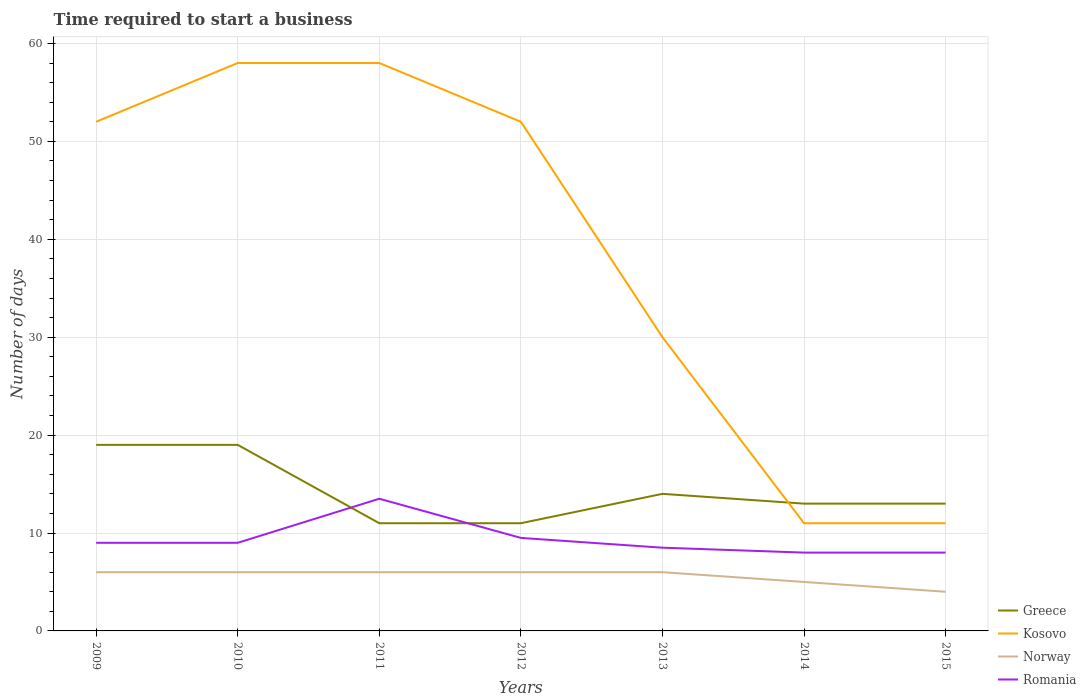Does the line corresponding to Norway intersect with the line corresponding to Greece?
Make the answer very short. No. Across all years, what is the maximum number of days required to start a business in Kosovo?
Make the answer very short. 11. In which year was the number of days required to start a business in Kosovo maximum?
Your answer should be compact. 2014. What is the total number of days required to start a business in Kosovo in the graph?
Your answer should be compact. 41. What is the difference between the highest and the lowest number of days required to start a business in Kosovo?
Offer a very short reply. 4. Is the number of days required to start a business in Romania strictly greater than the number of days required to start a business in Norway over the years?
Provide a short and direct response. No. What is the difference between two consecutive major ticks on the Y-axis?
Give a very brief answer. 10. Where does the legend appear in the graph?
Give a very brief answer. Bottom right. What is the title of the graph?
Offer a very short reply. Time required to start a business. Does "Togo" appear as one of the legend labels in the graph?
Offer a very short reply. No. What is the label or title of the Y-axis?
Give a very brief answer. Number of days. What is the Number of days in Kosovo in 2009?
Your answer should be compact. 52. What is the Number of days of Norway in 2009?
Your answer should be very brief. 6. What is the Number of days of Romania in 2009?
Provide a short and direct response. 9. What is the Number of days of Greece in 2010?
Your response must be concise. 19. What is the Number of days of Norway in 2010?
Keep it short and to the point. 6. What is the Number of days of Romania in 2010?
Give a very brief answer. 9. What is the Number of days in Greece in 2011?
Your answer should be very brief. 11. What is the Number of days of Romania in 2011?
Provide a short and direct response. 13.5. What is the Number of days in Greece in 2012?
Give a very brief answer. 11. What is the Number of days of Kosovo in 2012?
Provide a short and direct response. 52. What is the Number of days of Greece in 2014?
Make the answer very short. 13. What is the Number of days of Romania in 2014?
Your response must be concise. 8. What is the Number of days of Greece in 2015?
Your response must be concise. 13. What is the Number of days of Kosovo in 2015?
Provide a short and direct response. 11. Across all years, what is the maximum Number of days in Kosovo?
Your answer should be compact. 58. Across all years, what is the minimum Number of days in Romania?
Keep it short and to the point. 8. What is the total Number of days in Greece in the graph?
Ensure brevity in your answer.  100. What is the total Number of days of Kosovo in the graph?
Provide a short and direct response. 272. What is the total Number of days of Norway in the graph?
Ensure brevity in your answer.  39. What is the total Number of days of Romania in the graph?
Provide a succinct answer. 65.5. What is the difference between the Number of days of Greece in 2009 and that in 2010?
Offer a very short reply. 0. What is the difference between the Number of days in Kosovo in 2009 and that in 2010?
Provide a succinct answer. -6. What is the difference between the Number of days of Romania in 2009 and that in 2010?
Give a very brief answer. 0. What is the difference between the Number of days of Greece in 2009 and that in 2012?
Your response must be concise. 8. What is the difference between the Number of days in Kosovo in 2009 and that in 2012?
Your response must be concise. 0. What is the difference between the Number of days in Norway in 2009 and that in 2012?
Your response must be concise. 0. What is the difference between the Number of days of Kosovo in 2009 and that in 2013?
Your answer should be very brief. 22. What is the difference between the Number of days in Norway in 2009 and that in 2013?
Offer a terse response. 0. What is the difference between the Number of days of Romania in 2009 and that in 2013?
Offer a terse response. 0.5. What is the difference between the Number of days of Greece in 2009 and that in 2014?
Your answer should be very brief. 6. What is the difference between the Number of days of Romania in 2009 and that in 2015?
Provide a short and direct response. 1. What is the difference between the Number of days in Kosovo in 2010 and that in 2011?
Offer a very short reply. 0. What is the difference between the Number of days in Norway in 2010 and that in 2011?
Ensure brevity in your answer.  0. What is the difference between the Number of days of Greece in 2010 and that in 2012?
Provide a succinct answer. 8. What is the difference between the Number of days in Norway in 2010 and that in 2012?
Your answer should be very brief. 0. What is the difference between the Number of days of Romania in 2010 and that in 2012?
Provide a succinct answer. -0.5. What is the difference between the Number of days in Greece in 2010 and that in 2013?
Make the answer very short. 5. What is the difference between the Number of days of Romania in 2010 and that in 2013?
Keep it short and to the point. 0.5. What is the difference between the Number of days of Greece in 2010 and that in 2014?
Offer a very short reply. 6. What is the difference between the Number of days in Kosovo in 2010 and that in 2014?
Make the answer very short. 47. What is the difference between the Number of days in Norway in 2010 and that in 2014?
Ensure brevity in your answer.  1. What is the difference between the Number of days in Norway in 2010 and that in 2015?
Your answer should be very brief. 2. What is the difference between the Number of days of Greece in 2011 and that in 2012?
Offer a very short reply. 0. What is the difference between the Number of days in Norway in 2011 and that in 2012?
Ensure brevity in your answer.  0. What is the difference between the Number of days in Kosovo in 2011 and that in 2013?
Your answer should be compact. 28. What is the difference between the Number of days in Kosovo in 2011 and that in 2014?
Make the answer very short. 47. What is the difference between the Number of days of Romania in 2011 and that in 2014?
Make the answer very short. 5.5. What is the difference between the Number of days in Romania in 2011 and that in 2015?
Your response must be concise. 5.5. What is the difference between the Number of days of Greece in 2012 and that in 2013?
Ensure brevity in your answer.  -3. What is the difference between the Number of days of Kosovo in 2012 and that in 2013?
Make the answer very short. 22. What is the difference between the Number of days in Norway in 2012 and that in 2013?
Ensure brevity in your answer.  0. What is the difference between the Number of days in Norway in 2012 and that in 2014?
Offer a very short reply. 1. What is the difference between the Number of days in Greece in 2012 and that in 2015?
Offer a terse response. -2. What is the difference between the Number of days of Kosovo in 2012 and that in 2015?
Give a very brief answer. 41. What is the difference between the Number of days of Romania in 2013 and that in 2014?
Give a very brief answer. 0.5. What is the difference between the Number of days in Greece in 2013 and that in 2015?
Keep it short and to the point. 1. What is the difference between the Number of days in Kosovo in 2013 and that in 2015?
Provide a succinct answer. 19. What is the difference between the Number of days in Romania in 2013 and that in 2015?
Provide a succinct answer. 0.5. What is the difference between the Number of days in Kosovo in 2014 and that in 2015?
Provide a short and direct response. 0. What is the difference between the Number of days of Romania in 2014 and that in 2015?
Your answer should be compact. 0. What is the difference between the Number of days of Greece in 2009 and the Number of days of Kosovo in 2010?
Make the answer very short. -39. What is the difference between the Number of days in Greece in 2009 and the Number of days in Romania in 2010?
Offer a very short reply. 10. What is the difference between the Number of days in Kosovo in 2009 and the Number of days in Norway in 2010?
Ensure brevity in your answer.  46. What is the difference between the Number of days in Norway in 2009 and the Number of days in Romania in 2010?
Your answer should be very brief. -3. What is the difference between the Number of days of Greece in 2009 and the Number of days of Kosovo in 2011?
Offer a very short reply. -39. What is the difference between the Number of days of Greece in 2009 and the Number of days of Norway in 2011?
Ensure brevity in your answer.  13. What is the difference between the Number of days in Kosovo in 2009 and the Number of days in Romania in 2011?
Keep it short and to the point. 38.5. What is the difference between the Number of days in Greece in 2009 and the Number of days in Kosovo in 2012?
Make the answer very short. -33. What is the difference between the Number of days of Greece in 2009 and the Number of days of Norway in 2012?
Your answer should be very brief. 13. What is the difference between the Number of days of Greece in 2009 and the Number of days of Romania in 2012?
Give a very brief answer. 9.5. What is the difference between the Number of days in Kosovo in 2009 and the Number of days in Norway in 2012?
Provide a short and direct response. 46. What is the difference between the Number of days of Kosovo in 2009 and the Number of days of Romania in 2012?
Make the answer very short. 42.5. What is the difference between the Number of days of Greece in 2009 and the Number of days of Norway in 2013?
Offer a very short reply. 13. What is the difference between the Number of days in Kosovo in 2009 and the Number of days in Norway in 2013?
Make the answer very short. 46. What is the difference between the Number of days of Kosovo in 2009 and the Number of days of Romania in 2013?
Offer a terse response. 43.5. What is the difference between the Number of days of Norway in 2009 and the Number of days of Romania in 2013?
Provide a short and direct response. -2.5. What is the difference between the Number of days in Kosovo in 2009 and the Number of days in Romania in 2014?
Provide a short and direct response. 44. What is the difference between the Number of days of Norway in 2009 and the Number of days of Romania in 2014?
Your answer should be very brief. -2. What is the difference between the Number of days in Greece in 2009 and the Number of days in Kosovo in 2015?
Keep it short and to the point. 8. What is the difference between the Number of days of Kosovo in 2009 and the Number of days of Romania in 2015?
Provide a succinct answer. 44. What is the difference between the Number of days in Greece in 2010 and the Number of days in Kosovo in 2011?
Offer a very short reply. -39. What is the difference between the Number of days of Kosovo in 2010 and the Number of days of Romania in 2011?
Your response must be concise. 44.5. What is the difference between the Number of days of Greece in 2010 and the Number of days of Kosovo in 2012?
Your answer should be compact. -33. What is the difference between the Number of days of Greece in 2010 and the Number of days of Norway in 2012?
Ensure brevity in your answer.  13. What is the difference between the Number of days in Kosovo in 2010 and the Number of days in Romania in 2012?
Make the answer very short. 48.5. What is the difference between the Number of days of Norway in 2010 and the Number of days of Romania in 2012?
Offer a terse response. -3.5. What is the difference between the Number of days in Greece in 2010 and the Number of days in Romania in 2013?
Make the answer very short. 10.5. What is the difference between the Number of days of Kosovo in 2010 and the Number of days of Norway in 2013?
Give a very brief answer. 52. What is the difference between the Number of days of Kosovo in 2010 and the Number of days of Romania in 2013?
Give a very brief answer. 49.5. What is the difference between the Number of days of Greece in 2010 and the Number of days of Kosovo in 2014?
Give a very brief answer. 8. What is the difference between the Number of days of Greece in 2010 and the Number of days of Norway in 2014?
Make the answer very short. 14. What is the difference between the Number of days in Greece in 2010 and the Number of days in Romania in 2014?
Ensure brevity in your answer.  11. What is the difference between the Number of days in Norway in 2010 and the Number of days in Romania in 2014?
Offer a terse response. -2. What is the difference between the Number of days in Greece in 2010 and the Number of days in Kosovo in 2015?
Give a very brief answer. 8. What is the difference between the Number of days in Kosovo in 2010 and the Number of days in Norway in 2015?
Offer a terse response. 54. What is the difference between the Number of days of Kosovo in 2010 and the Number of days of Romania in 2015?
Make the answer very short. 50. What is the difference between the Number of days of Norway in 2010 and the Number of days of Romania in 2015?
Give a very brief answer. -2. What is the difference between the Number of days of Greece in 2011 and the Number of days of Kosovo in 2012?
Provide a short and direct response. -41. What is the difference between the Number of days in Greece in 2011 and the Number of days in Norway in 2012?
Ensure brevity in your answer.  5. What is the difference between the Number of days of Kosovo in 2011 and the Number of days of Norway in 2012?
Your response must be concise. 52. What is the difference between the Number of days in Kosovo in 2011 and the Number of days in Romania in 2012?
Give a very brief answer. 48.5. What is the difference between the Number of days in Norway in 2011 and the Number of days in Romania in 2012?
Give a very brief answer. -3.5. What is the difference between the Number of days of Greece in 2011 and the Number of days of Norway in 2013?
Your answer should be compact. 5. What is the difference between the Number of days in Kosovo in 2011 and the Number of days in Norway in 2013?
Provide a short and direct response. 52. What is the difference between the Number of days of Kosovo in 2011 and the Number of days of Romania in 2013?
Provide a short and direct response. 49.5. What is the difference between the Number of days of Norway in 2011 and the Number of days of Romania in 2013?
Your answer should be very brief. -2.5. What is the difference between the Number of days in Greece in 2011 and the Number of days in Kosovo in 2014?
Ensure brevity in your answer.  0. What is the difference between the Number of days of Greece in 2011 and the Number of days of Norway in 2014?
Give a very brief answer. 6. What is the difference between the Number of days in Kosovo in 2011 and the Number of days in Norway in 2014?
Your answer should be very brief. 53. What is the difference between the Number of days in Norway in 2011 and the Number of days in Romania in 2014?
Keep it short and to the point. -2. What is the difference between the Number of days of Greece in 2011 and the Number of days of Kosovo in 2015?
Offer a very short reply. 0. What is the difference between the Number of days in Greece in 2011 and the Number of days in Norway in 2015?
Provide a short and direct response. 7. What is the difference between the Number of days in Kosovo in 2011 and the Number of days in Norway in 2015?
Give a very brief answer. 54. What is the difference between the Number of days of Kosovo in 2011 and the Number of days of Romania in 2015?
Ensure brevity in your answer.  50. What is the difference between the Number of days in Greece in 2012 and the Number of days in Kosovo in 2013?
Your response must be concise. -19. What is the difference between the Number of days in Greece in 2012 and the Number of days in Romania in 2013?
Provide a succinct answer. 2.5. What is the difference between the Number of days of Kosovo in 2012 and the Number of days of Norway in 2013?
Your answer should be compact. 46. What is the difference between the Number of days of Kosovo in 2012 and the Number of days of Romania in 2013?
Your response must be concise. 43.5. What is the difference between the Number of days of Greece in 2012 and the Number of days of Kosovo in 2014?
Provide a succinct answer. 0. What is the difference between the Number of days of Greece in 2012 and the Number of days of Norway in 2014?
Provide a short and direct response. 6. What is the difference between the Number of days in Greece in 2012 and the Number of days in Romania in 2014?
Offer a terse response. 3. What is the difference between the Number of days of Kosovo in 2012 and the Number of days of Norway in 2014?
Provide a succinct answer. 47. What is the difference between the Number of days in Kosovo in 2012 and the Number of days in Romania in 2015?
Your answer should be compact. 44. What is the difference between the Number of days in Greece in 2013 and the Number of days in Norway in 2014?
Give a very brief answer. 9. What is the difference between the Number of days of Greece in 2013 and the Number of days of Romania in 2014?
Offer a terse response. 6. What is the difference between the Number of days in Kosovo in 2013 and the Number of days in Norway in 2014?
Your answer should be compact. 25. What is the difference between the Number of days in Kosovo in 2013 and the Number of days in Romania in 2014?
Make the answer very short. 22. What is the difference between the Number of days of Norway in 2013 and the Number of days of Romania in 2014?
Your answer should be very brief. -2. What is the difference between the Number of days of Greece in 2013 and the Number of days of Kosovo in 2015?
Give a very brief answer. 3. What is the difference between the Number of days in Greece in 2013 and the Number of days in Norway in 2015?
Your answer should be very brief. 10. What is the difference between the Number of days in Greece in 2014 and the Number of days in Norway in 2015?
Offer a terse response. 9. What is the difference between the Number of days in Kosovo in 2014 and the Number of days in Norway in 2015?
Offer a very short reply. 7. What is the difference between the Number of days of Kosovo in 2014 and the Number of days of Romania in 2015?
Ensure brevity in your answer.  3. What is the difference between the Number of days in Norway in 2014 and the Number of days in Romania in 2015?
Make the answer very short. -3. What is the average Number of days in Greece per year?
Your answer should be very brief. 14.29. What is the average Number of days in Kosovo per year?
Offer a very short reply. 38.86. What is the average Number of days of Norway per year?
Offer a very short reply. 5.57. What is the average Number of days of Romania per year?
Make the answer very short. 9.36. In the year 2009, what is the difference between the Number of days of Greece and Number of days of Kosovo?
Keep it short and to the point. -33. In the year 2009, what is the difference between the Number of days in Greece and Number of days in Norway?
Ensure brevity in your answer.  13. In the year 2009, what is the difference between the Number of days of Greece and Number of days of Romania?
Provide a succinct answer. 10. In the year 2010, what is the difference between the Number of days of Greece and Number of days of Kosovo?
Ensure brevity in your answer.  -39. In the year 2010, what is the difference between the Number of days in Kosovo and Number of days in Romania?
Give a very brief answer. 49. In the year 2011, what is the difference between the Number of days of Greece and Number of days of Kosovo?
Offer a terse response. -47. In the year 2011, what is the difference between the Number of days of Greece and Number of days of Norway?
Provide a succinct answer. 5. In the year 2011, what is the difference between the Number of days of Kosovo and Number of days of Romania?
Ensure brevity in your answer.  44.5. In the year 2012, what is the difference between the Number of days in Greece and Number of days in Kosovo?
Make the answer very short. -41. In the year 2012, what is the difference between the Number of days in Greece and Number of days in Romania?
Give a very brief answer. 1.5. In the year 2012, what is the difference between the Number of days of Kosovo and Number of days of Romania?
Give a very brief answer. 42.5. In the year 2012, what is the difference between the Number of days in Norway and Number of days in Romania?
Your answer should be compact. -3.5. In the year 2013, what is the difference between the Number of days of Greece and Number of days of Norway?
Your answer should be compact. 8. In the year 2013, what is the difference between the Number of days of Greece and Number of days of Romania?
Keep it short and to the point. 5.5. In the year 2013, what is the difference between the Number of days in Norway and Number of days in Romania?
Offer a very short reply. -2.5. In the year 2014, what is the difference between the Number of days in Greece and Number of days in Romania?
Your answer should be compact. 5. In the year 2014, what is the difference between the Number of days of Kosovo and Number of days of Romania?
Keep it short and to the point. 3. In the year 2014, what is the difference between the Number of days of Norway and Number of days of Romania?
Your answer should be very brief. -3. In the year 2015, what is the difference between the Number of days of Greece and Number of days of Kosovo?
Ensure brevity in your answer.  2. What is the ratio of the Number of days in Kosovo in 2009 to that in 2010?
Provide a short and direct response. 0.9. What is the ratio of the Number of days of Norway in 2009 to that in 2010?
Your answer should be compact. 1. What is the ratio of the Number of days of Romania in 2009 to that in 2010?
Your response must be concise. 1. What is the ratio of the Number of days in Greece in 2009 to that in 2011?
Give a very brief answer. 1.73. What is the ratio of the Number of days of Kosovo in 2009 to that in 2011?
Your response must be concise. 0.9. What is the ratio of the Number of days in Romania in 2009 to that in 2011?
Offer a very short reply. 0.67. What is the ratio of the Number of days of Greece in 2009 to that in 2012?
Keep it short and to the point. 1.73. What is the ratio of the Number of days in Norway in 2009 to that in 2012?
Your answer should be compact. 1. What is the ratio of the Number of days in Greece in 2009 to that in 2013?
Your answer should be compact. 1.36. What is the ratio of the Number of days of Kosovo in 2009 to that in 2013?
Offer a very short reply. 1.73. What is the ratio of the Number of days in Norway in 2009 to that in 2013?
Offer a terse response. 1. What is the ratio of the Number of days in Romania in 2009 to that in 2013?
Provide a short and direct response. 1.06. What is the ratio of the Number of days in Greece in 2009 to that in 2014?
Keep it short and to the point. 1.46. What is the ratio of the Number of days of Kosovo in 2009 to that in 2014?
Offer a terse response. 4.73. What is the ratio of the Number of days in Romania in 2009 to that in 2014?
Provide a succinct answer. 1.12. What is the ratio of the Number of days of Greece in 2009 to that in 2015?
Provide a succinct answer. 1.46. What is the ratio of the Number of days of Kosovo in 2009 to that in 2015?
Offer a very short reply. 4.73. What is the ratio of the Number of days of Greece in 2010 to that in 2011?
Provide a succinct answer. 1.73. What is the ratio of the Number of days in Kosovo in 2010 to that in 2011?
Keep it short and to the point. 1. What is the ratio of the Number of days of Greece in 2010 to that in 2012?
Offer a very short reply. 1.73. What is the ratio of the Number of days in Kosovo in 2010 to that in 2012?
Your answer should be very brief. 1.12. What is the ratio of the Number of days in Greece in 2010 to that in 2013?
Make the answer very short. 1.36. What is the ratio of the Number of days of Kosovo in 2010 to that in 2013?
Keep it short and to the point. 1.93. What is the ratio of the Number of days in Norway in 2010 to that in 2013?
Provide a short and direct response. 1. What is the ratio of the Number of days of Romania in 2010 to that in 2013?
Make the answer very short. 1.06. What is the ratio of the Number of days in Greece in 2010 to that in 2014?
Your response must be concise. 1.46. What is the ratio of the Number of days in Kosovo in 2010 to that in 2014?
Your answer should be compact. 5.27. What is the ratio of the Number of days of Norway in 2010 to that in 2014?
Keep it short and to the point. 1.2. What is the ratio of the Number of days in Romania in 2010 to that in 2014?
Your answer should be compact. 1.12. What is the ratio of the Number of days of Greece in 2010 to that in 2015?
Provide a succinct answer. 1.46. What is the ratio of the Number of days in Kosovo in 2010 to that in 2015?
Offer a very short reply. 5.27. What is the ratio of the Number of days in Norway in 2010 to that in 2015?
Your answer should be compact. 1.5. What is the ratio of the Number of days of Romania in 2010 to that in 2015?
Offer a very short reply. 1.12. What is the ratio of the Number of days of Greece in 2011 to that in 2012?
Your answer should be compact. 1. What is the ratio of the Number of days of Kosovo in 2011 to that in 2012?
Your answer should be very brief. 1.12. What is the ratio of the Number of days of Romania in 2011 to that in 2012?
Make the answer very short. 1.42. What is the ratio of the Number of days in Greece in 2011 to that in 2013?
Your answer should be compact. 0.79. What is the ratio of the Number of days in Kosovo in 2011 to that in 2013?
Make the answer very short. 1.93. What is the ratio of the Number of days of Norway in 2011 to that in 2013?
Provide a short and direct response. 1. What is the ratio of the Number of days in Romania in 2011 to that in 2013?
Offer a very short reply. 1.59. What is the ratio of the Number of days in Greece in 2011 to that in 2014?
Provide a succinct answer. 0.85. What is the ratio of the Number of days in Kosovo in 2011 to that in 2014?
Make the answer very short. 5.27. What is the ratio of the Number of days in Norway in 2011 to that in 2014?
Offer a terse response. 1.2. What is the ratio of the Number of days of Romania in 2011 to that in 2014?
Ensure brevity in your answer.  1.69. What is the ratio of the Number of days of Greece in 2011 to that in 2015?
Provide a short and direct response. 0.85. What is the ratio of the Number of days in Kosovo in 2011 to that in 2015?
Provide a succinct answer. 5.27. What is the ratio of the Number of days of Romania in 2011 to that in 2015?
Provide a short and direct response. 1.69. What is the ratio of the Number of days in Greece in 2012 to that in 2013?
Your answer should be compact. 0.79. What is the ratio of the Number of days of Kosovo in 2012 to that in 2013?
Your response must be concise. 1.73. What is the ratio of the Number of days of Norway in 2012 to that in 2013?
Provide a short and direct response. 1. What is the ratio of the Number of days of Romania in 2012 to that in 2013?
Your answer should be very brief. 1.12. What is the ratio of the Number of days in Greece in 2012 to that in 2014?
Offer a terse response. 0.85. What is the ratio of the Number of days in Kosovo in 2012 to that in 2014?
Make the answer very short. 4.73. What is the ratio of the Number of days in Norway in 2012 to that in 2014?
Make the answer very short. 1.2. What is the ratio of the Number of days in Romania in 2012 to that in 2014?
Offer a very short reply. 1.19. What is the ratio of the Number of days in Greece in 2012 to that in 2015?
Keep it short and to the point. 0.85. What is the ratio of the Number of days of Kosovo in 2012 to that in 2015?
Your answer should be compact. 4.73. What is the ratio of the Number of days in Norway in 2012 to that in 2015?
Your response must be concise. 1.5. What is the ratio of the Number of days of Romania in 2012 to that in 2015?
Ensure brevity in your answer.  1.19. What is the ratio of the Number of days in Kosovo in 2013 to that in 2014?
Your answer should be compact. 2.73. What is the ratio of the Number of days in Norway in 2013 to that in 2014?
Give a very brief answer. 1.2. What is the ratio of the Number of days in Romania in 2013 to that in 2014?
Make the answer very short. 1.06. What is the ratio of the Number of days of Greece in 2013 to that in 2015?
Provide a succinct answer. 1.08. What is the ratio of the Number of days in Kosovo in 2013 to that in 2015?
Provide a succinct answer. 2.73. What is the ratio of the Number of days of Romania in 2013 to that in 2015?
Offer a very short reply. 1.06. What is the ratio of the Number of days in Greece in 2014 to that in 2015?
Offer a very short reply. 1. What is the ratio of the Number of days of Kosovo in 2014 to that in 2015?
Your response must be concise. 1. What is the difference between the highest and the second highest Number of days in Kosovo?
Offer a terse response. 0. What is the difference between the highest and the second highest Number of days in Romania?
Make the answer very short. 4. What is the difference between the highest and the lowest Number of days of Greece?
Your answer should be compact. 8. What is the difference between the highest and the lowest Number of days in Norway?
Keep it short and to the point. 2. 